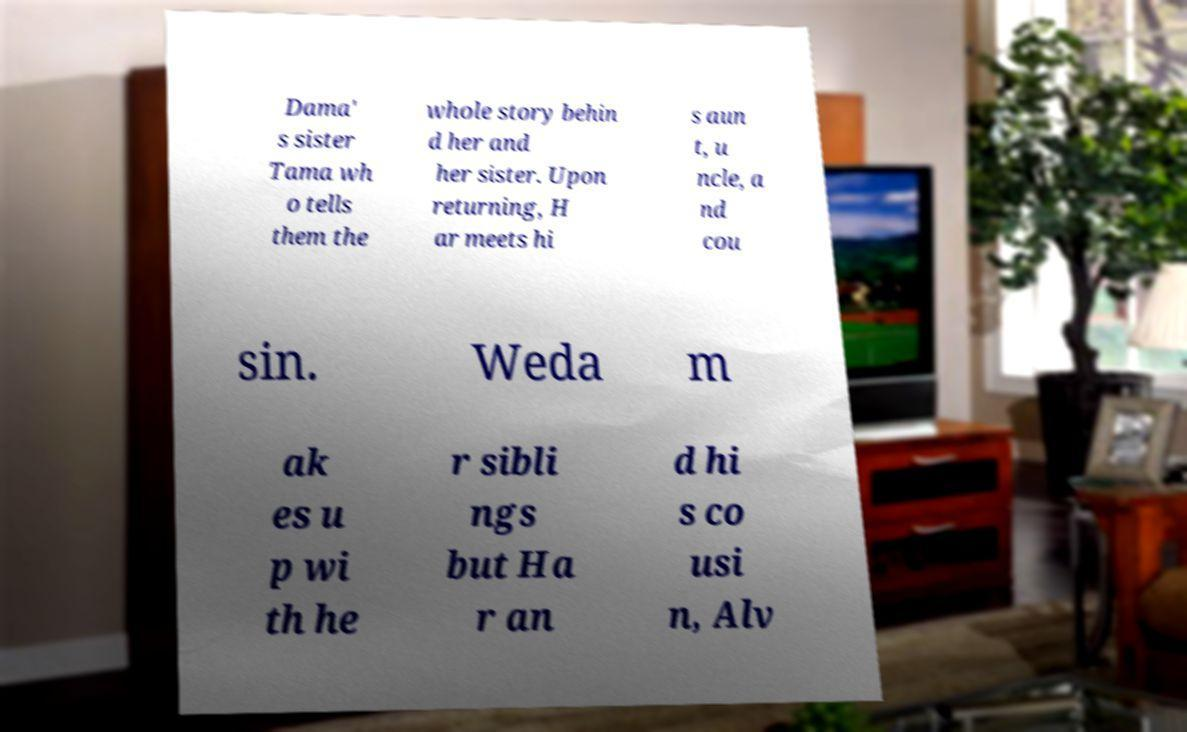There's text embedded in this image that I need extracted. Can you transcribe it verbatim? Dama' s sister Tama wh o tells them the whole story behin d her and her sister. Upon returning, H ar meets hi s aun t, u ncle, a nd cou sin. Weda m ak es u p wi th he r sibli ngs but Ha r an d hi s co usi n, Alv 